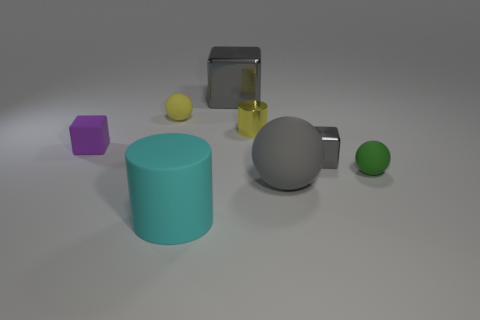Add 1 big metal objects. How many objects exist? 9 Subtract all blocks. How many objects are left? 5 Subtract all large gray blocks. Subtract all large matte cylinders. How many objects are left? 6 Add 6 big gray spheres. How many big gray spheres are left? 7 Add 7 metal blocks. How many metal blocks exist? 9 Subtract 0 brown cylinders. How many objects are left? 8 